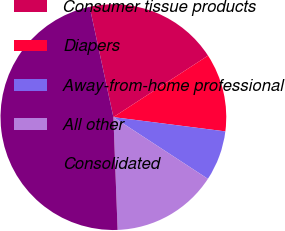<chart> <loc_0><loc_0><loc_500><loc_500><pie_chart><fcel>Consumer tissue products<fcel>Diapers<fcel>Away-from-home professional<fcel>All other<fcel>Consolidated<nl><fcel>19.2%<fcel>11.19%<fcel>7.19%<fcel>15.2%<fcel>47.22%<nl></chart> 